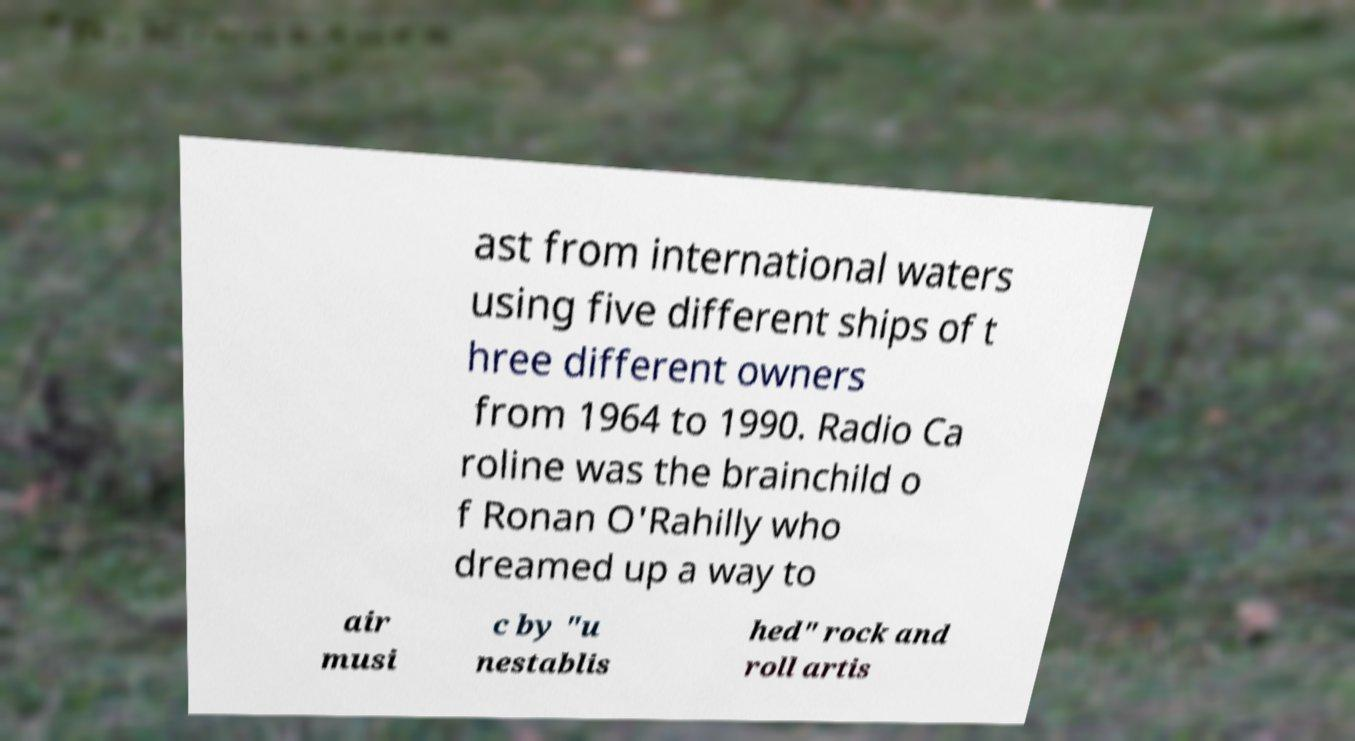There's text embedded in this image that I need extracted. Can you transcribe it verbatim? ast from international waters using five different ships of t hree different owners from 1964 to 1990. Radio Ca roline was the brainchild o f Ronan O'Rahilly who dreamed up a way to air musi c by "u nestablis hed" rock and roll artis 